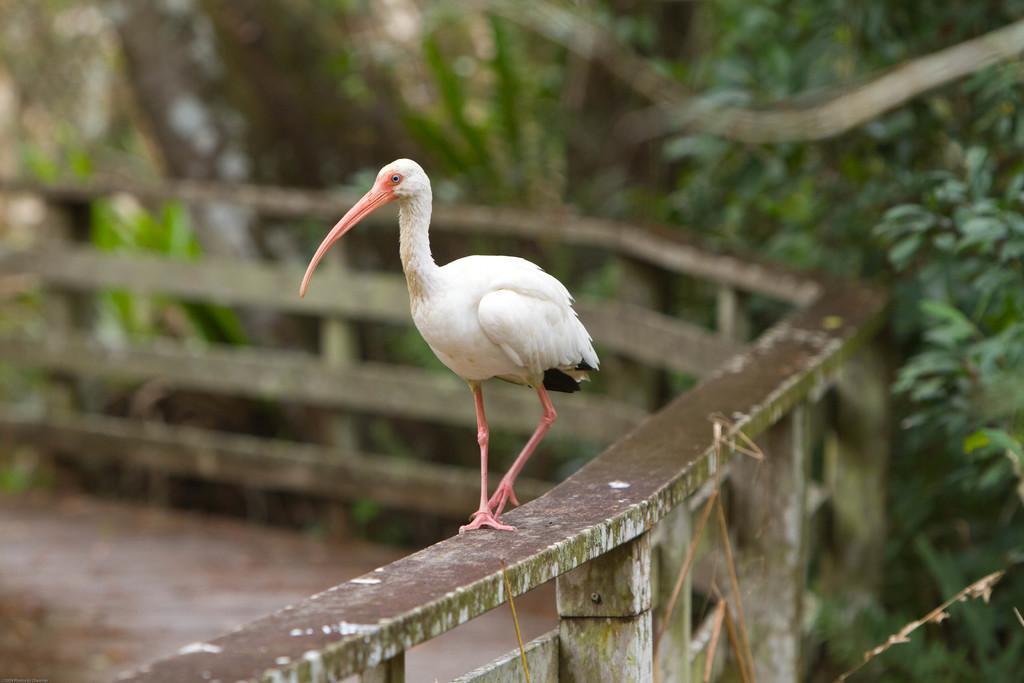Describe this image in one or two sentences. In this image there is a duck on the railing. In the background there are trees. 